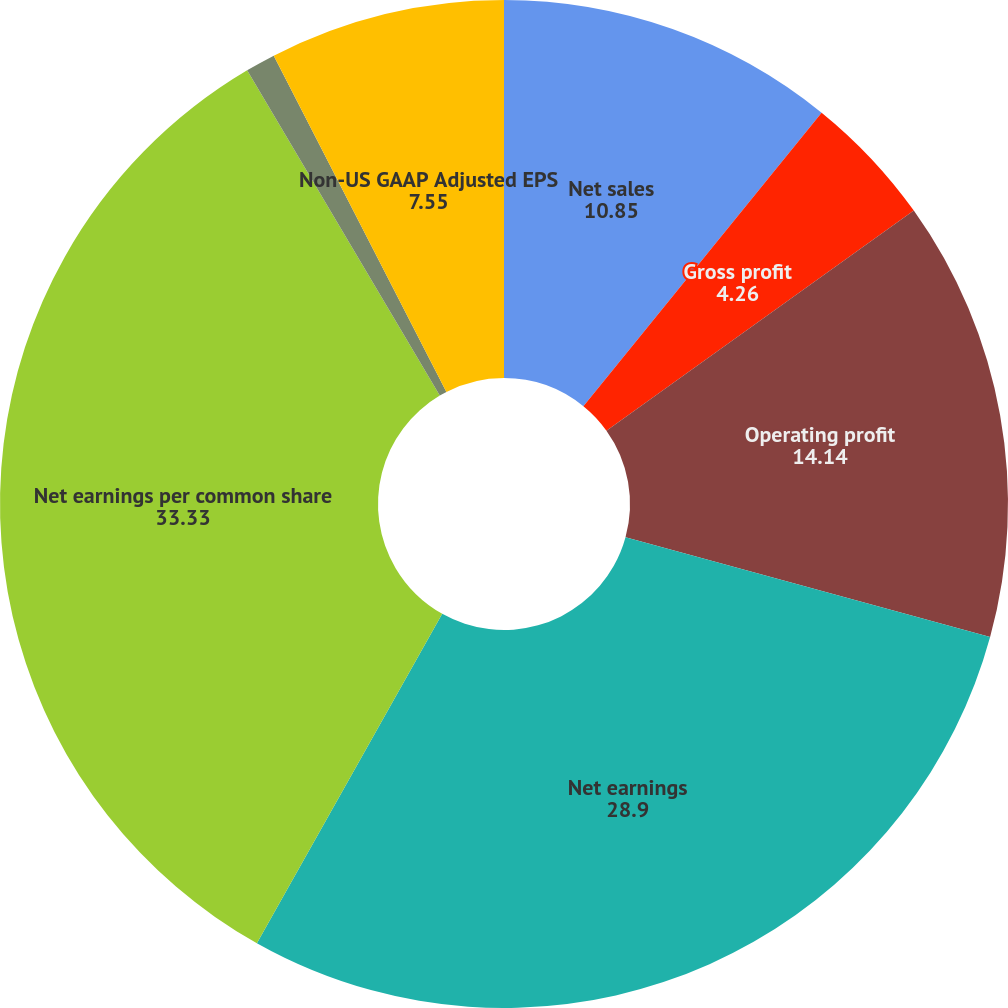Convert chart. <chart><loc_0><loc_0><loc_500><loc_500><pie_chart><fcel>Net sales<fcel>Gross profit<fcel>Operating profit<fcel>Net earnings<fcel>Net earnings per common share<fcel>Non-US GAAP Adjusted<fcel>Non-US GAAP Adjusted EPS<nl><fcel>10.85%<fcel>4.26%<fcel>14.14%<fcel>28.9%<fcel>33.33%<fcel>0.96%<fcel>7.55%<nl></chart> 